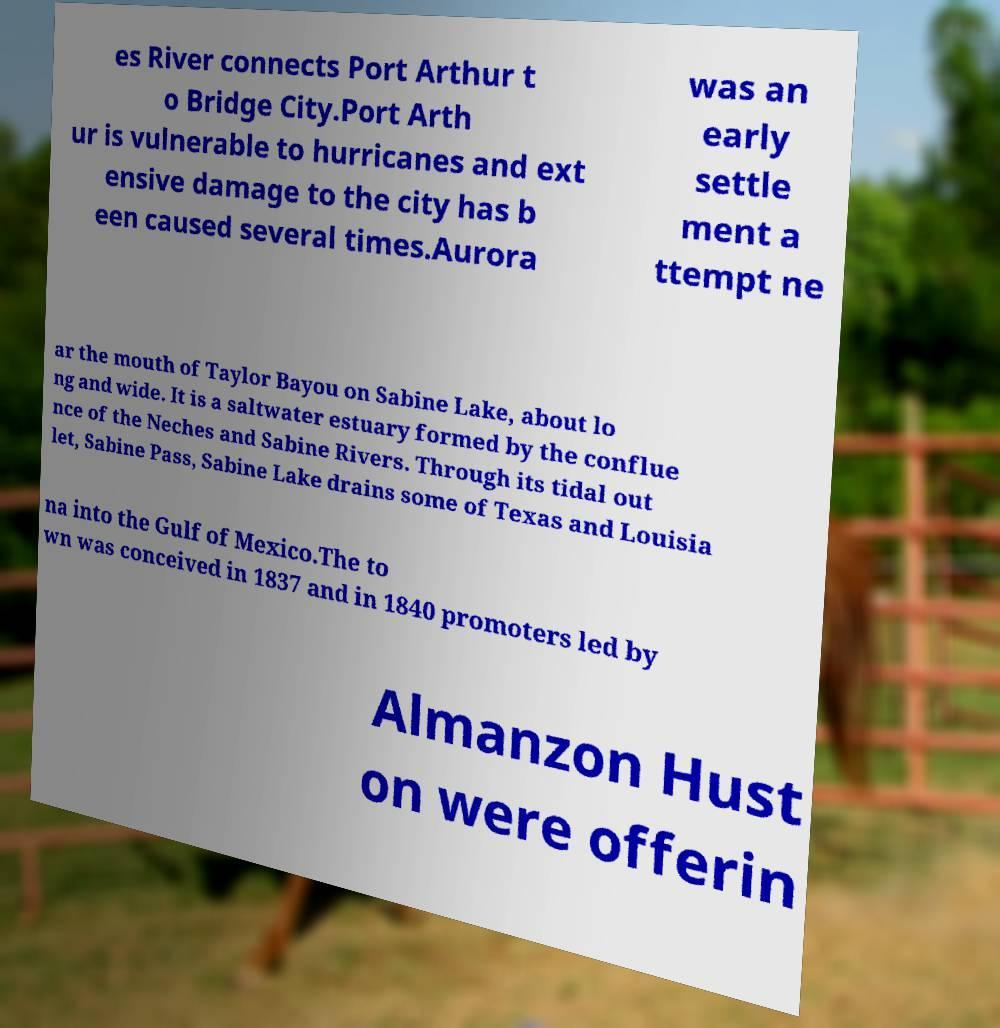I need the written content from this picture converted into text. Can you do that? es River connects Port Arthur t o Bridge City.Port Arth ur is vulnerable to hurricanes and ext ensive damage to the city has b een caused several times.Aurora was an early settle ment a ttempt ne ar the mouth of Taylor Bayou on Sabine Lake, about lo ng and wide. It is a saltwater estuary formed by the conflue nce of the Neches and Sabine Rivers. Through its tidal out let, Sabine Pass, Sabine Lake drains some of Texas and Louisia na into the Gulf of Mexico.The to wn was conceived in 1837 and in 1840 promoters led by Almanzon Hust on were offerin 